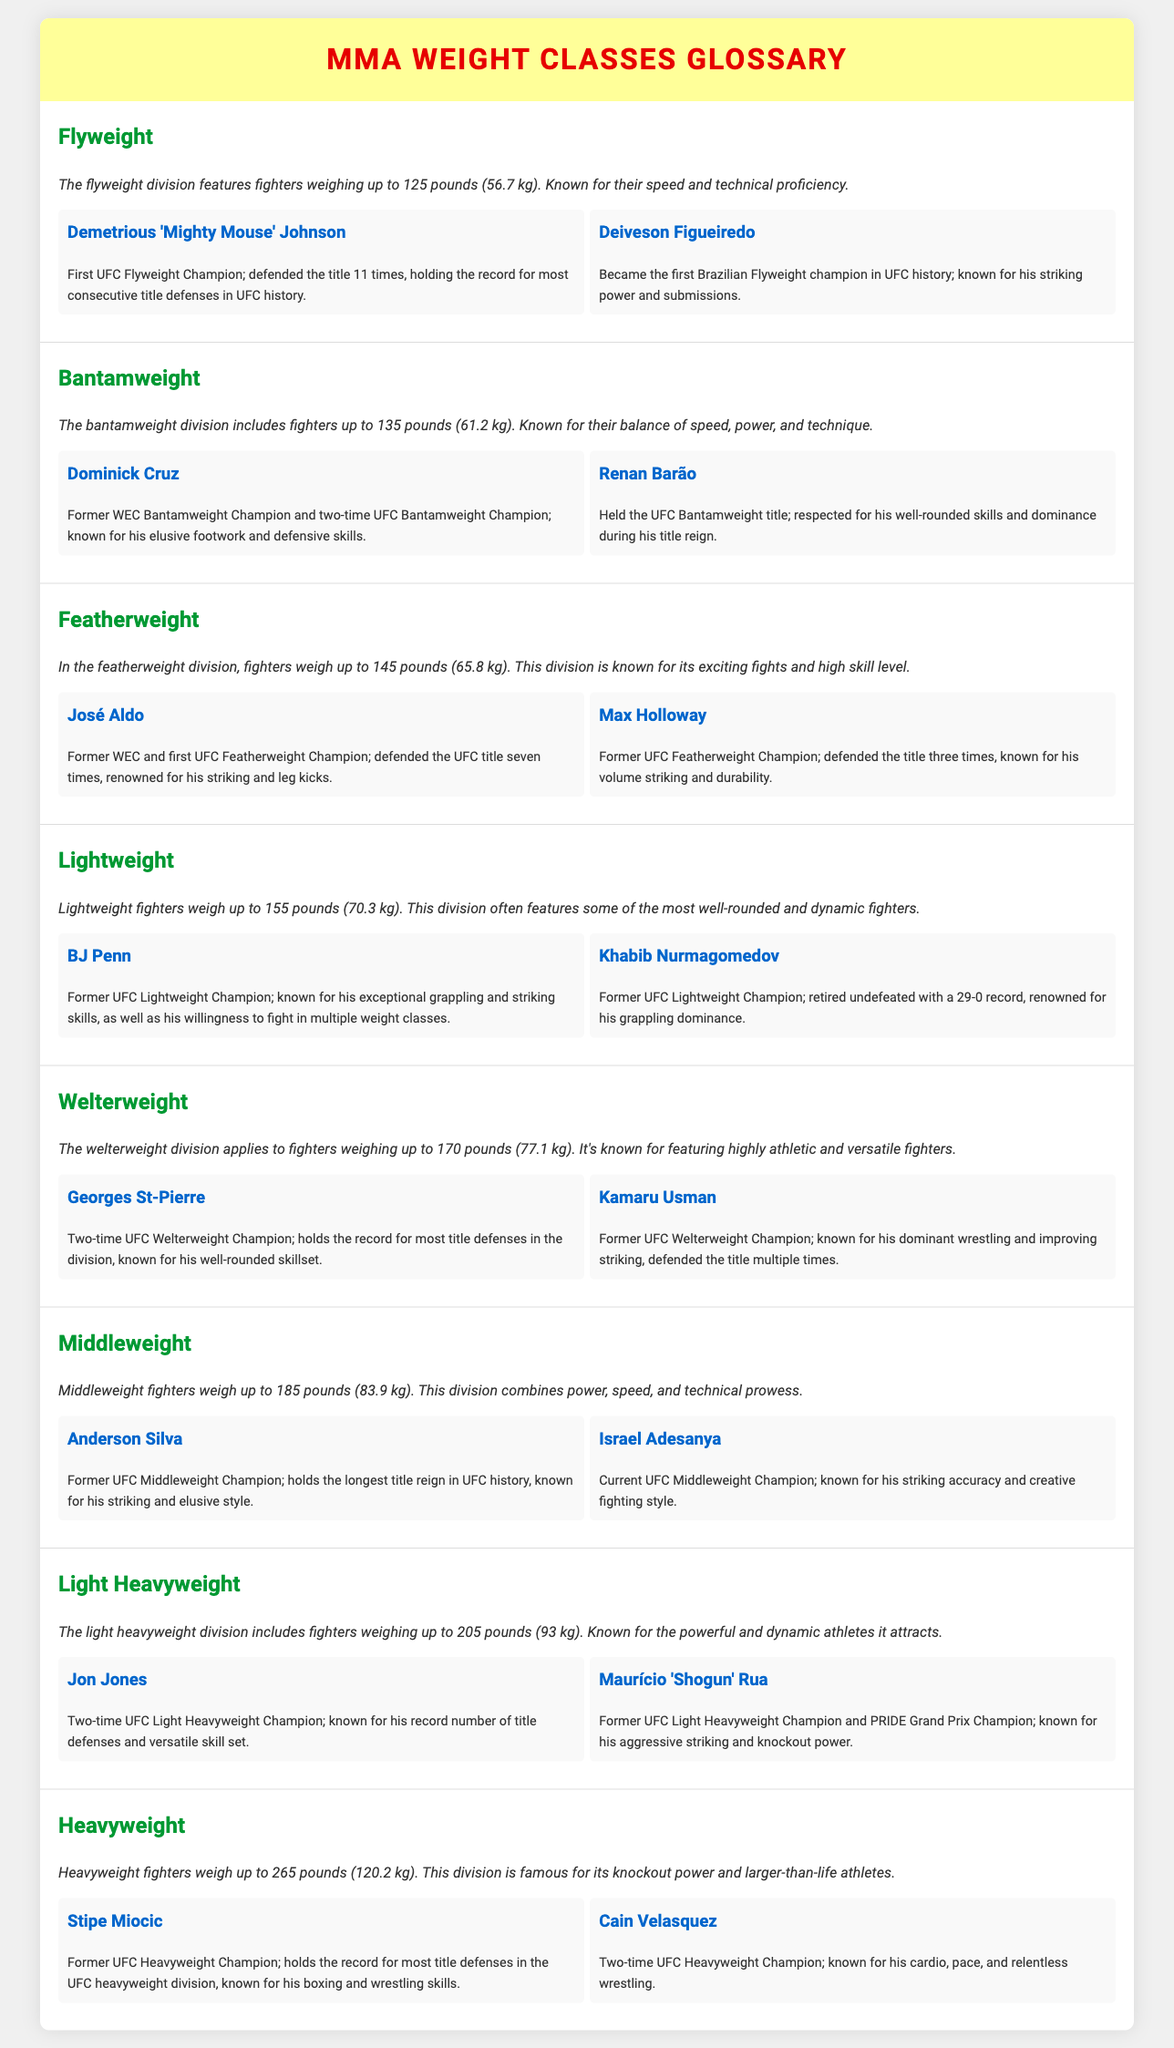What is the weight limit for the Flyweight division? The Flyweight division features fighters weighing up to 125 pounds (56.7 kg).
Answer: 125 pounds Who was the first Brazilian Flyweight champion? Deiveson Figueiredo is recognized as the first Brazilian Flyweight champion in UFC history.
Answer: Deiveson Figueiredo How many times did José Aldo defend his title? José Aldo defended the UFC title seven times during his reign.
Answer: seven Who holds the record for most title defenses in the UFC heavyweight division? Stipe Miocic holds the record for most title defenses in the UFC heavyweight division.
Answer: Stipe Miocic Which fighter has a retired undefeated record of 29-0? Khabib Nurmagomedov is known for retiring undefeated with a record of 29-0.
Answer: Khabib Nurmagomedov What characterizes the Bantamweight division? The bantamweight division includes fighters up to 135 pounds (61.2 kg).
Answer: up to 135 pounds Who is known for his leg kicks in the Featherweight division? José Aldo is renowned for his striking and leg kicks in the Featherweight division.
Answer: José Aldo What is the highest weight limit for the Light Heavyweight division? The light heavyweight division includes fighters weighing up to 205 pounds (93 kg).
Answer: 205 pounds Who is the current champion of the Middleweight division? Israel Adesanya is recognized as the current UFC Middleweight Champion.
Answer: Israel Adesanya 